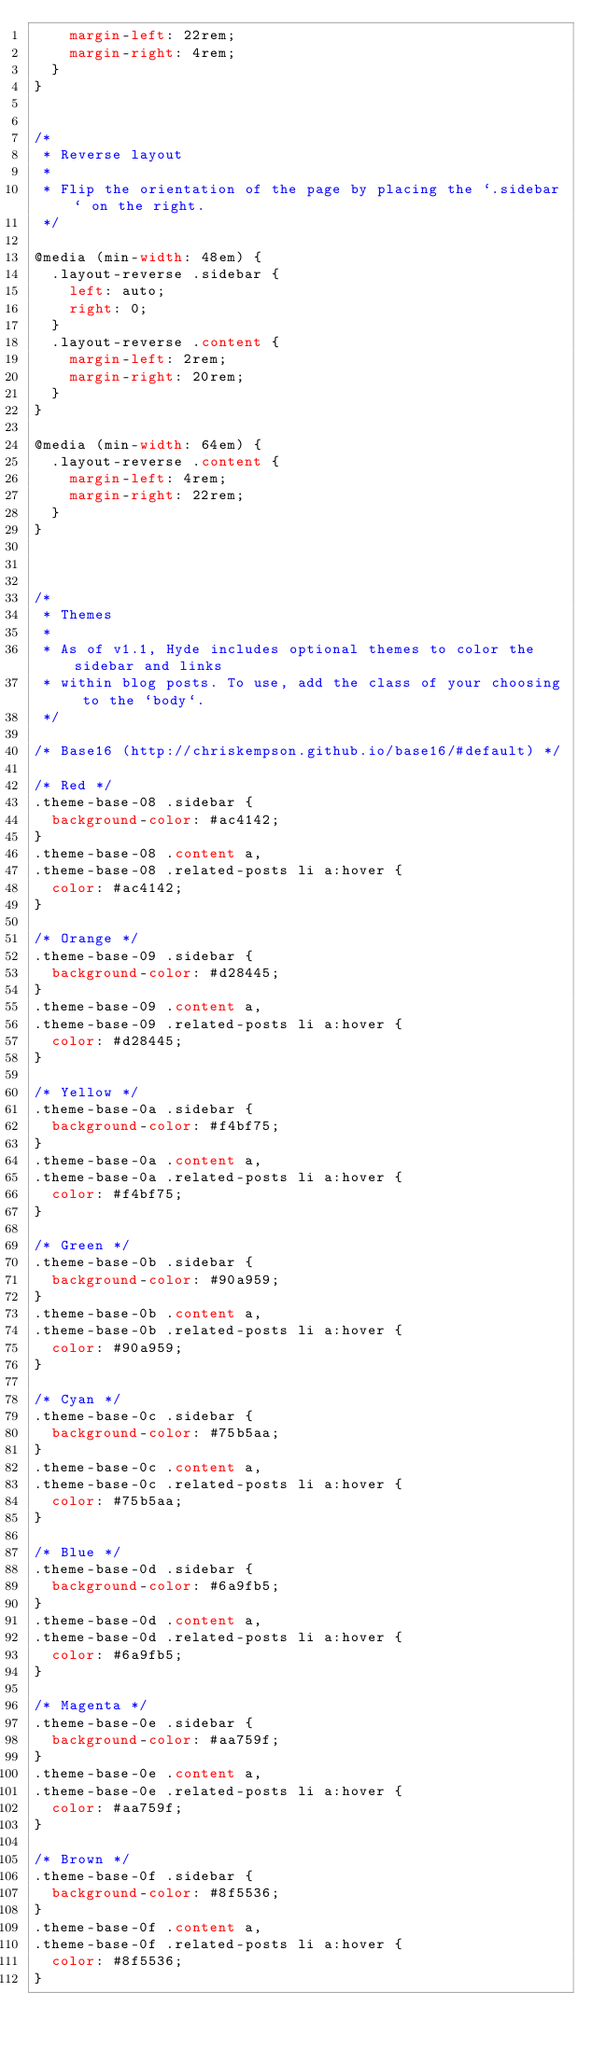Convert code to text. <code><loc_0><loc_0><loc_500><loc_500><_CSS_>    margin-left: 22rem;
    margin-right: 4rem;
  }
}


/*
 * Reverse layout
 *
 * Flip the orientation of the page by placing the `.sidebar` on the right.
 */

@media (min-width: 48em) {
  .layout-reverse .sidebar {
    left: auto;
    right: 0;
  }
  .layout-reverse .content {
    margin-left: 2rem;
    margin-right: 20rem;
  }
}

@media (min-width: 64em) {
  .layout-reverse .content {
    margin-left: 4rem;
    margin-right: 22rem;
  }
}



/*
 * Themes
 *
 * As of v1.1, Hyde includes optional themes to color the sidebar and links
 * within blog posts. To use, add the class of your choosing to the `body`.
 */

/* Base16 (http://chriskempson.github.io/base16/#default) */

/* Red */
.theme-base-08 .sidebar {
  background-color: #ac4142;
}
.theme-base-08 .content a,
.theme-base-08 .related-posts li a:hover {
  color: #ac4142;
}

/* Orange */
.theme-base-09 .sidebar {
  background-color: #d28445;
}
.theme-base-09 .content a,
.theme-base-09 .related-posts li a:hover {
  color: #d28445;
}

/* Yellow */
.theme-base-0a .sidebar {
  background-color: #f4bf75;
}
.theme-base-0a .content a,
.theme-base-0a .related-posts li a:hover {
  color: #f4bf75;
}

/* Green */
.theme-base-0b .sidebar {
  background-color: #90a959;
}
.theme-base-0b .content a,
.theme-base-0b .related-posts li a:hover {
  color: #90a959;
}

/* Cyan */
.theme-base-0c .sidebar {
  background-color: #75b5aa;
}
.theme-base-0c .content a,
.theme-base-0c .related-posts li a:hover {
  color: #75b5aa;
}

/* Blue */
.theme-base-0d .sidebar {
  background-color: #6a9fb5;
}
.theme-base-0d .content a,
.theme-base-0d .related-posts li a:hover {
  color: #6a9fb5;
}

/* Magenta */
.theme-base-0e .sidebar {
  background-color: #aa759f;
}
.theme-base-0e .content a,
.theme-base-0e .related-posts li a:hover {
  color: #aa759f;
}

/* Brown */
.theme-base-0f .sidebar {
  background-color: #8f5536;
}
.theme-base-0f .content a,
.theme-base-0f .related-posts li a:hover {
  color: #8f5536;
}
</code> 